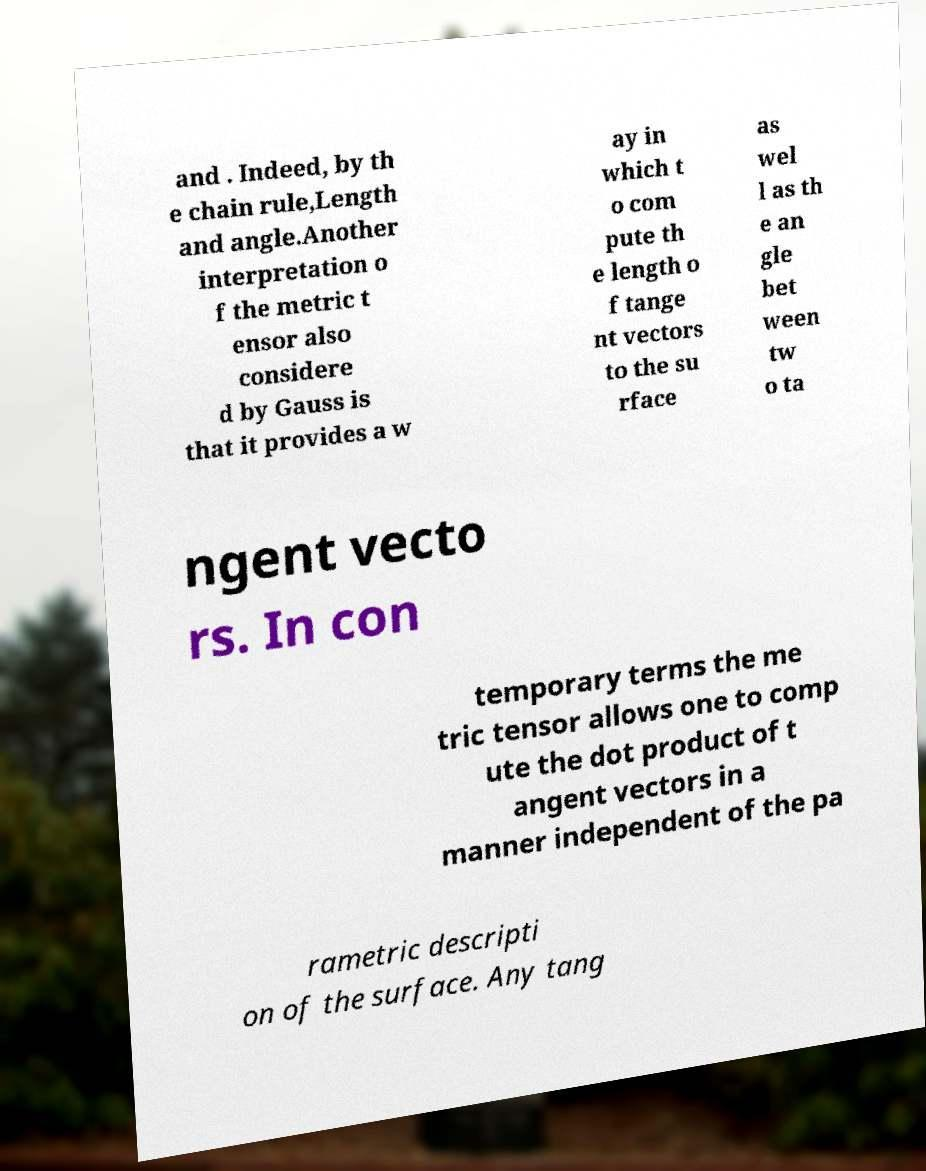Could you assist in decoding the text presented in this image and type it out clearly? and . Indeed, by th e chain rule,Length and angle.Another interpretation o f the metric t ensor also considere d by Gauss is that it provides a w ay in which t o com pute th e length o f tange nt vectors to the su rface as wel l as th e an gle bet ween tw o ta ngent vecto rs. In con temporary terms the me tric tensor allows one to comp ute the dot product of t angent vectors in a manner independent of the pa rametric descripti on of the surface. Any tang 